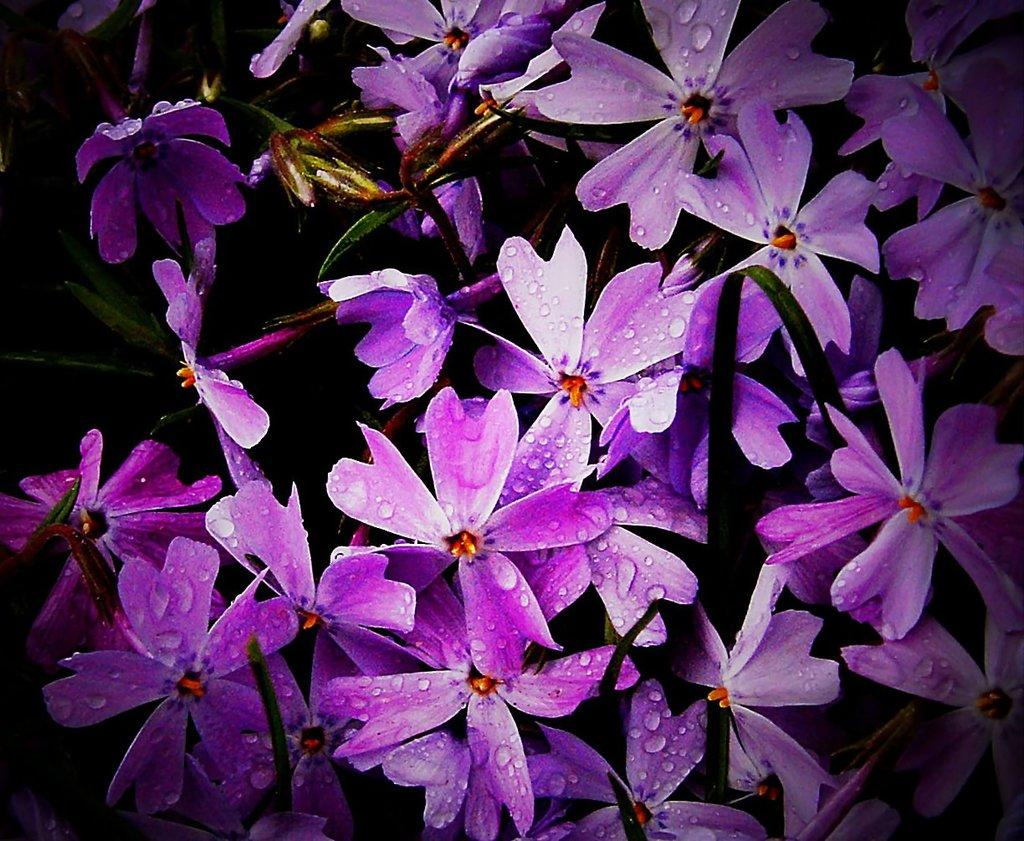What type of plants are in the image? There are flowers in the image. What color are the flowers? The flowers are purple in color. Can you describe the appearance of the flowers? There are water droplets on the flowers. What is the color of the leaves in the image? The leaves in the image are green. How would you describe the background of the image? The background of the image is dark. What type of shoes is the beggar wearing in the image? There is no beggar or shoes present in the image; it features flowers with water droplets and green leaves against a dark background. What type of corn can be seen growing in the image? There is no corn present in the image; it features flowers with water droplets and green leaves against a dark background. 